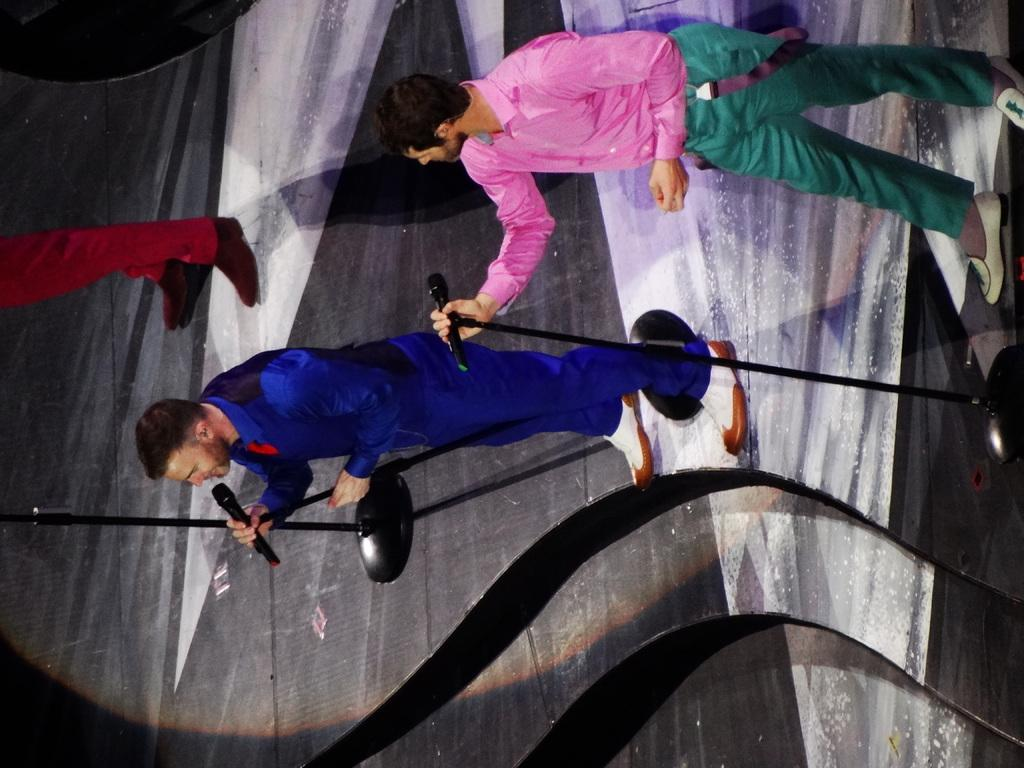How many people are in the image? There are three people in the image. What are the people doing in the image? The people are standing on the floor. Can you describe what the two men are holding? The two men are holding microphones. What is the temper of the family in the image? There is no mention of a family in the image, and therefore no information about their temper can be provided. 